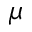Convert formula to latex. <formula><loc_0><loc_0><loc_500><loc_500>\mu</formula> 